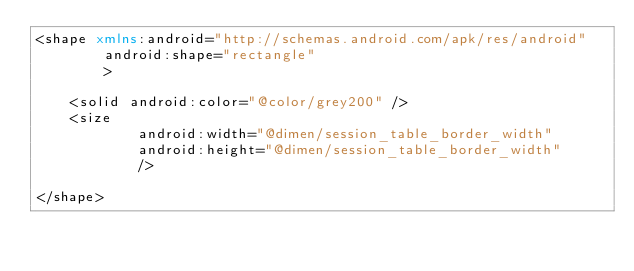<code> <loc_0><loc_0><loc_500><loc_500><_XML_><shape xmlns:android="http://schemas.android.com/apk/res/android"
        android:shape="rectangle"
        >

    <solid android:color="@color/grey200" />
    <size
            android:width="@dimen/session_table_border_width"
            android:height="@dimen/session_table_border_width"
            />

</shape>
</code> 